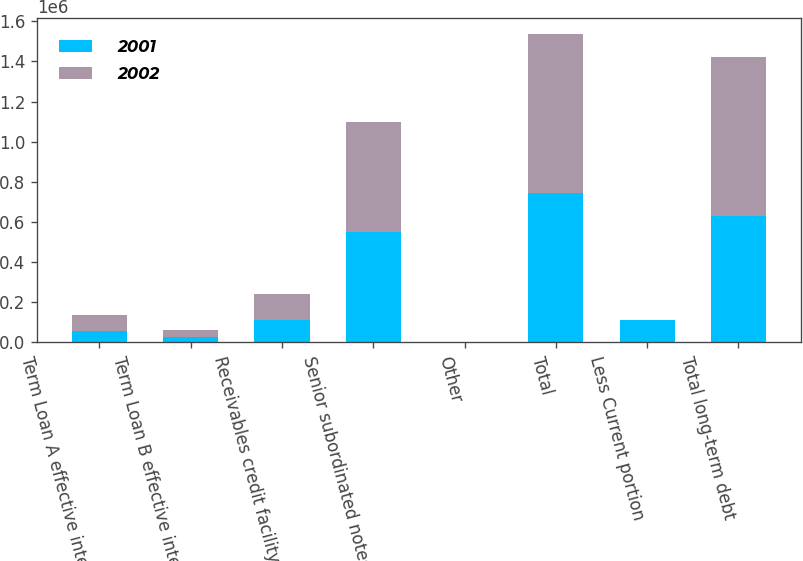Convert chart to OTSL. <chart><loc_0><loc_0><loc_500><loc_500><stacked_bar_chart><ecel><fcel>Term Loan A effective interest<fcel>Term Loan B effective interest<fcel>Receivables credit facility<fcel>Senior subordinated notes<fcel>Other<fcel>Total<fcel>Less Current portion<fcel>Total long-term debt<nl><fcel>2001<fcel>54618<fcel>24382<fcel>113000<fcel>550000<fcel>213<fcel>742213<fcel>113094<fcel>629119<nl><fcel>2002<fcel>82272<fcel>36728<fcel>126000<fcel>550000<fcel>217<fcel>795217<fcel>54<fcel>795163<nl></chart> 